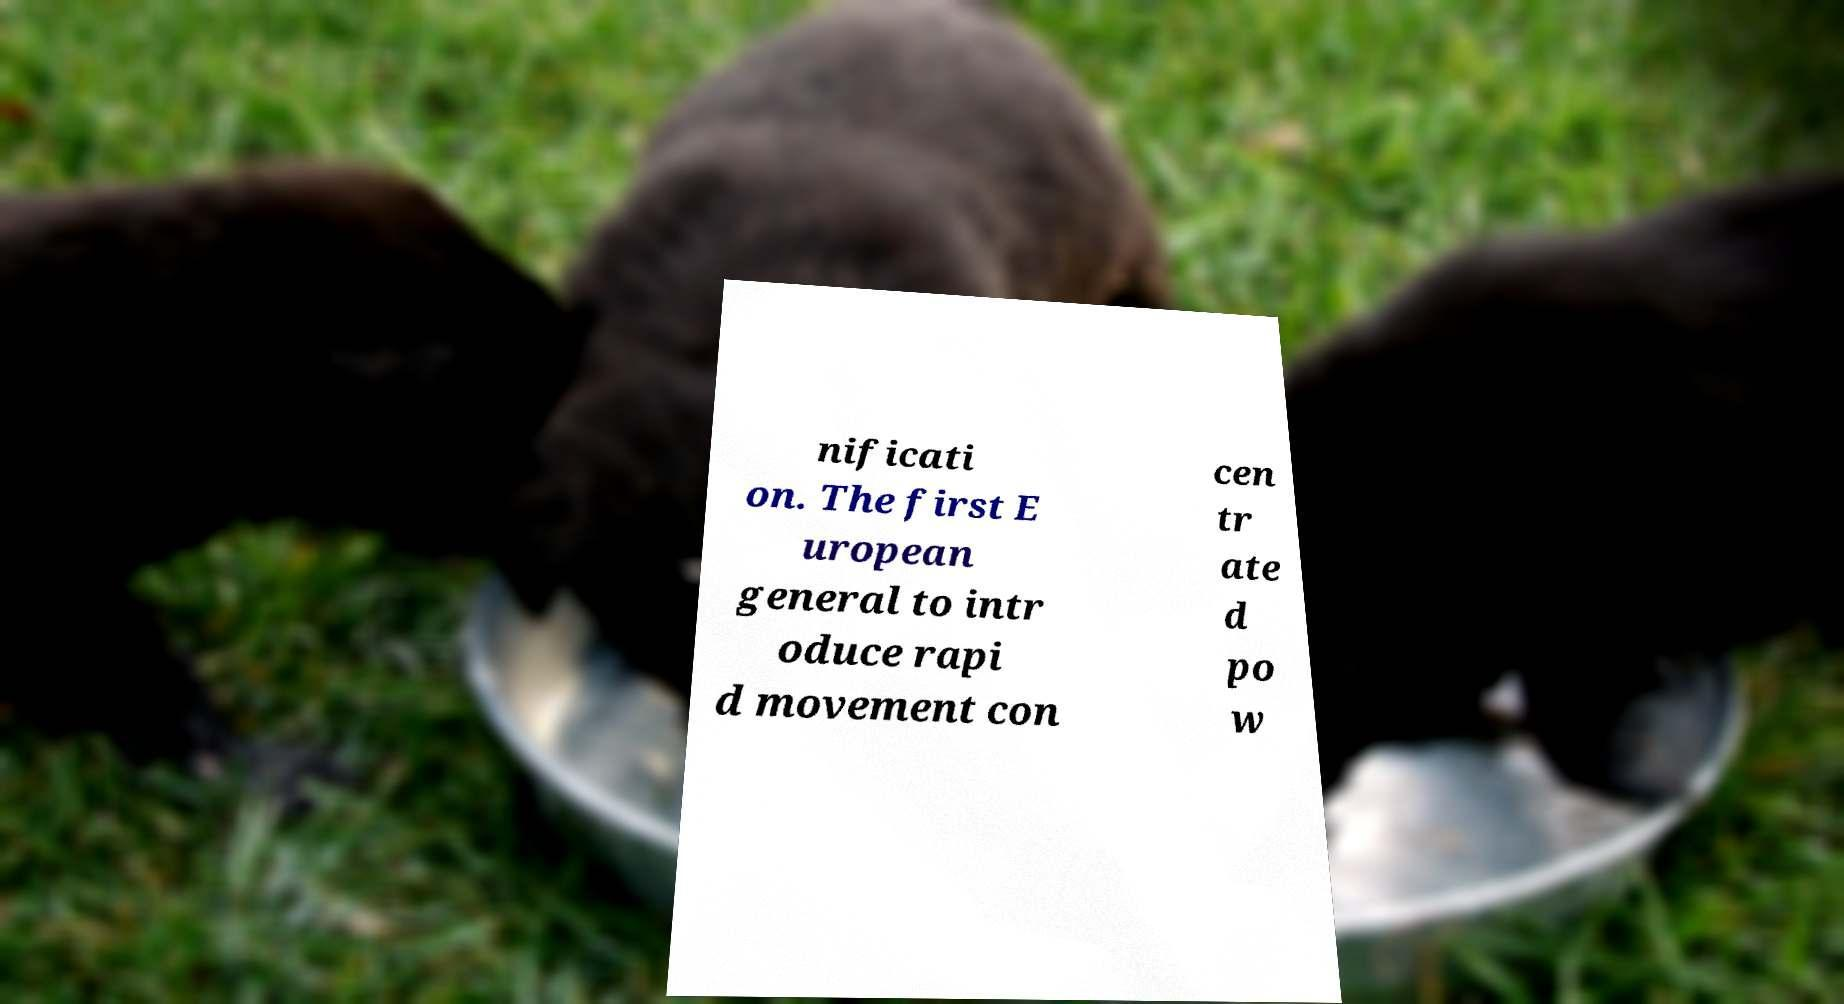Can you accurately transcribe the text from the provided image for me? nificati on. The first E uropean general to intr oduce rapi d movement con cen tr ate d po w 